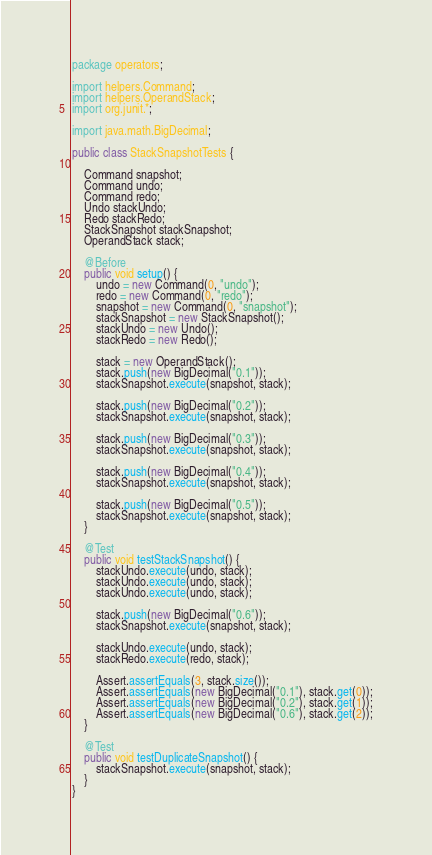Convert code to text. <code><loc_0><loc_0><loc_500><loc_500><_Java_>package operators;

import helpers.Command;
import helpers.OperandStack;
import org.junit.*;

import java.math.BigDecimal;

public class StackSnapshotTests {

    Command snapshot;
    Command undo;
    Command redo;
    Undo stackUndo;
    Redo stackRedo;
    StackSnapshot stackSnapshot;
    OperandStack stack;

    @Before
    public void setup() {
        undo = new Command(0, "undo");
        redo = new Command(0, "redo");
        snapshot = new Command(0, "snapshot");
        stackSnapshot = new StackSnapshot();
        stackUndo = new Undo();
        stackRedo = new Redo();

        stack = new OperandStack();
        stack.push(new BigDecimal("0.1"));
        stackSnapshot.execute(snapshot, stack);

        stack.push(new BigDecimal("0.2"));
        stackSnapshot.execute(snapshot, stack);

        stack.push(new BigDecimal("0.3"));
        stackSnapshot.execute(snapshot, stack);

        stack.push(new BigDecimal("0.4"));
        stackSnapshot.execute(snapshot, stack);

        stack.push(new BigDecimal("0.5"));
        stackSnapshot.execute(snapshot, stack);
    }

    @Test
    public void testStackSnapshot() {
        stackUndo.execute(undo, stack);
        stackUndo.execute(undo, stack);
        stackUndo.execute(undo, stack);

        stack.push(new BigDecimal("0.6"));
        stackSnapshot.execute(snapshot, stack);

        stackUndo.execute(undo, stack);
        stackRedo.execute(redo, stack);

        Assert.assertEquals(3, stack.size());
        Assert.assertEquals(new BigDecimal("0.1"), stack.get(0));
        Assert.assertEquals(new BigDecimal("0.2"), stack.get(1));
        Assert.assertEquals(new BigDecimal("0.6"), stack.get(2));
    }

    @Test
    public void testDuplicateSnapshot() {
        stackSnapshot.execute(snapshot, stack);
    }
}
</code> 